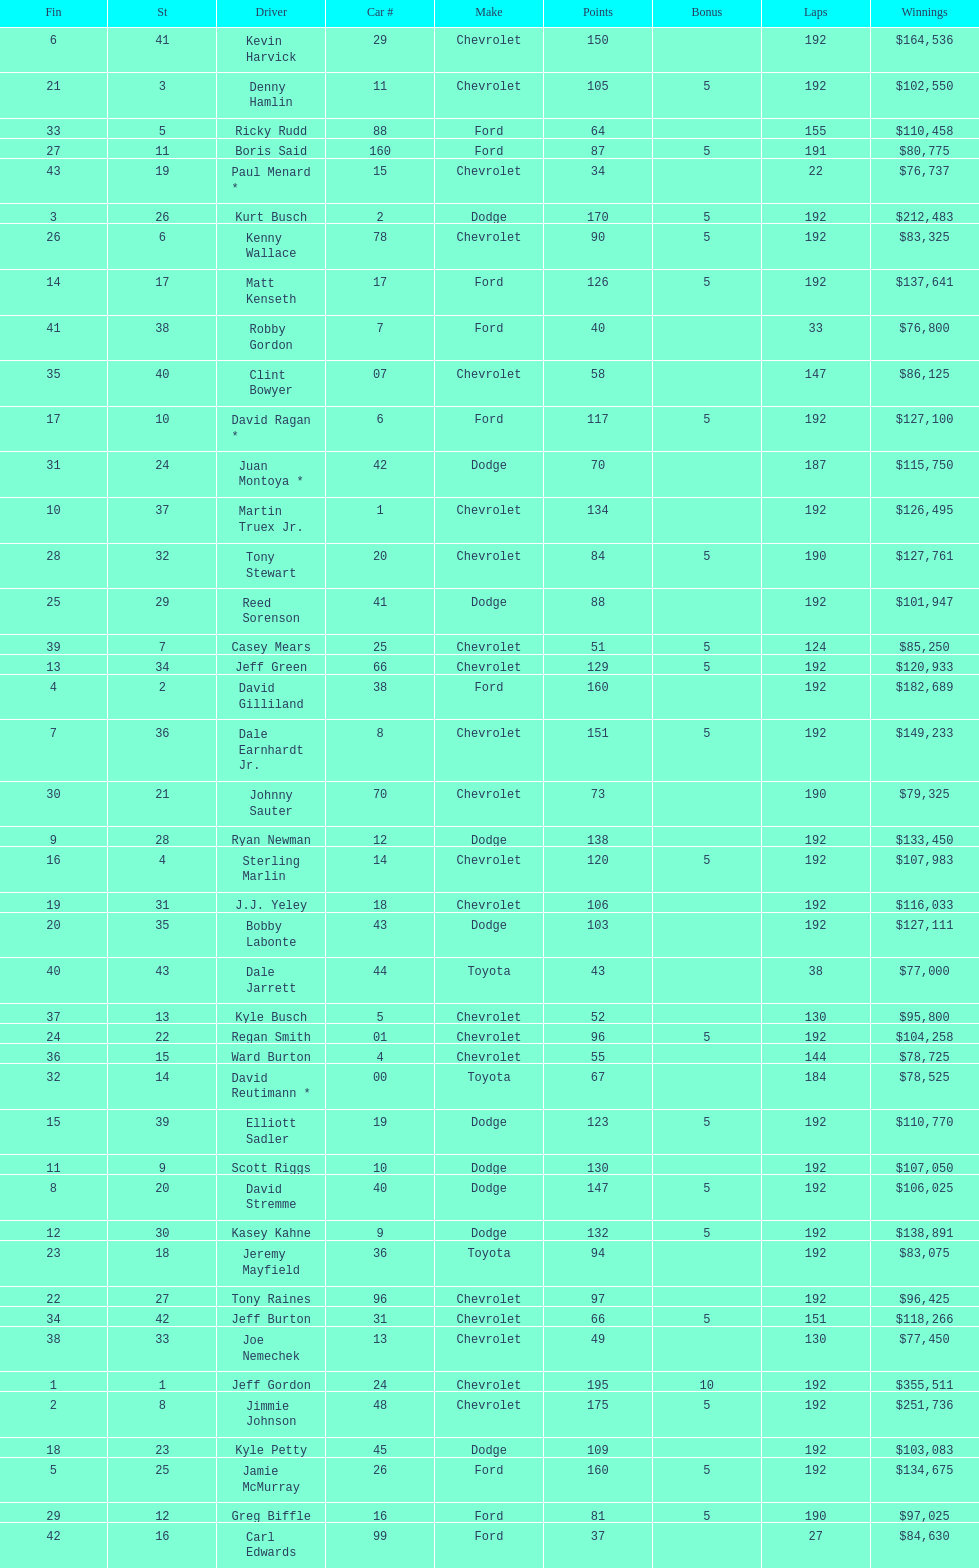Who is first in number of winnings on this list? Jeff Gordon. 